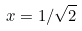<formula> <loc_0><loc_0><loc_500><loc_500>x = 1 / \sqrt { 2 }</formula> 